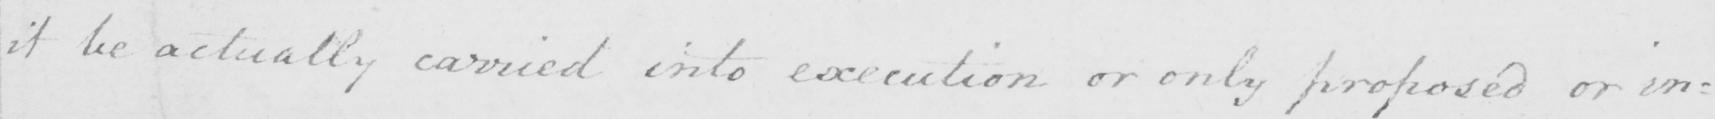What text is written in this handwritten line? it be actually carried into execution or only proposed or in= 